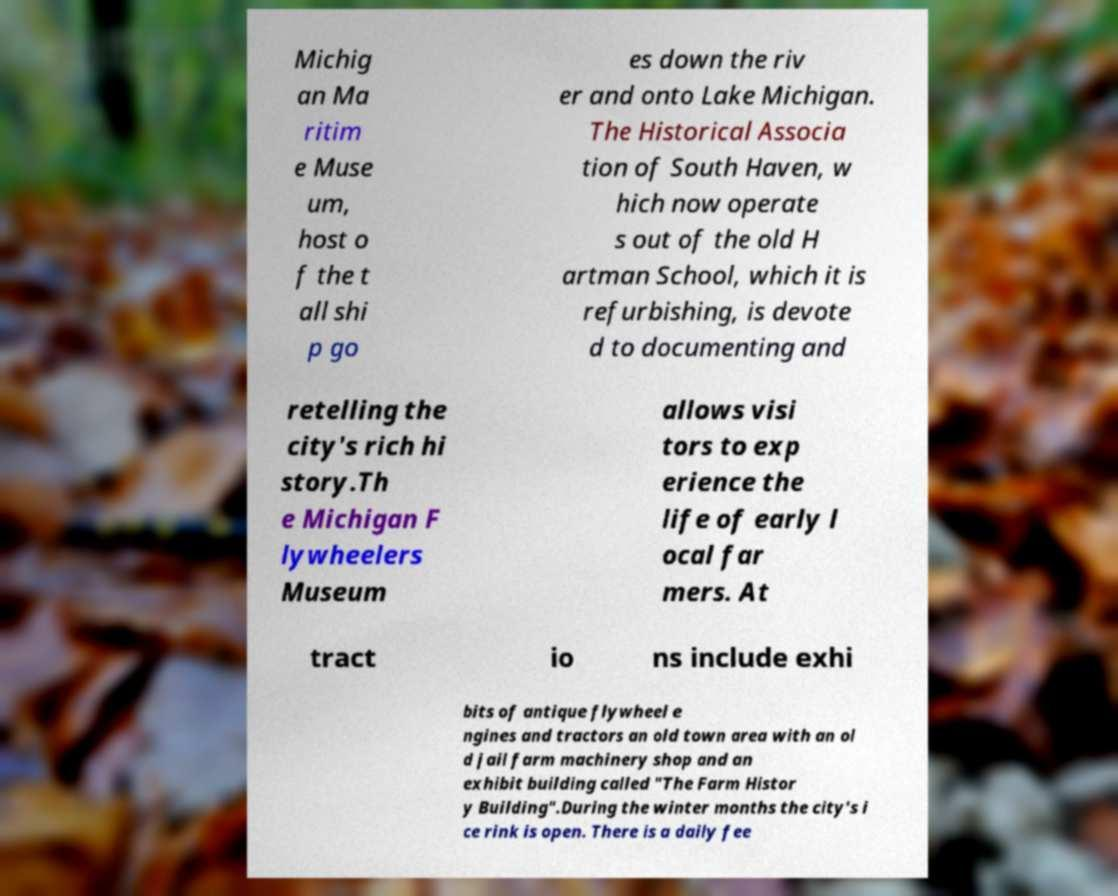Please read and relay the text visible in this image. What does it say? Michig an Ma ritim e Muse um, host o f the t all shi p go es down the riv er and onto Lake Michigan. The Historical Associa tion of South Haven, w hich now operate s out of the old H artman School, which it is refurbishing, is devote d to documenting and retelling the city's rich hi story.Th e Michigan F lywheelers Museum allows visi tors to exp erience the life of early l ocal far mers. At tract io ns include exhi bits of antique flywheel e ngines and tractors an old town area with an ol d jail farm machinery shop and an exhibit building called "The Farm Histor y Building".During the winter months the city's i ce rink is open. There is a daily fee 